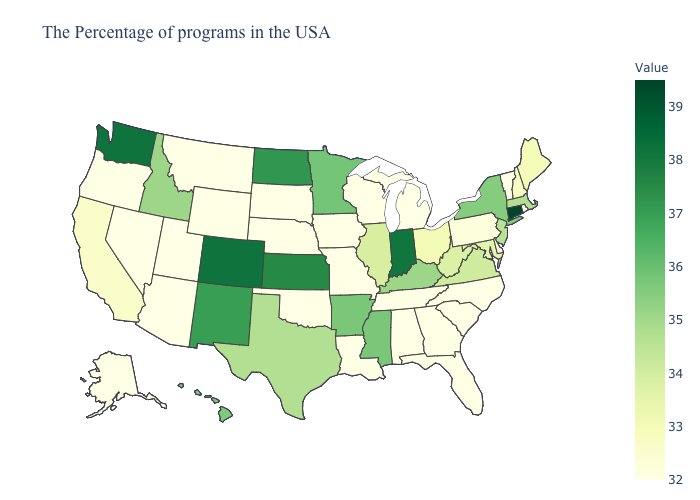Does Utah have the highest value in the West?
Answer briefly. No. Among the states that border Arkansas , which have the highest value?
Write a very short answer. Mississippi. Does Alaska have a lower value than Maine?
Concise answer only. Yes. 